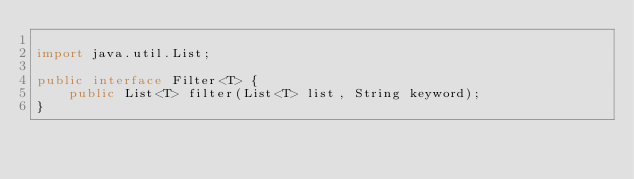<code> <loc_0><loc_0><loc_500><loc_500><_Java_>
import java.util.List;

public interface Filter<T> {
	public List<T> filter(List<T> list, String keyword);
}
</code> 